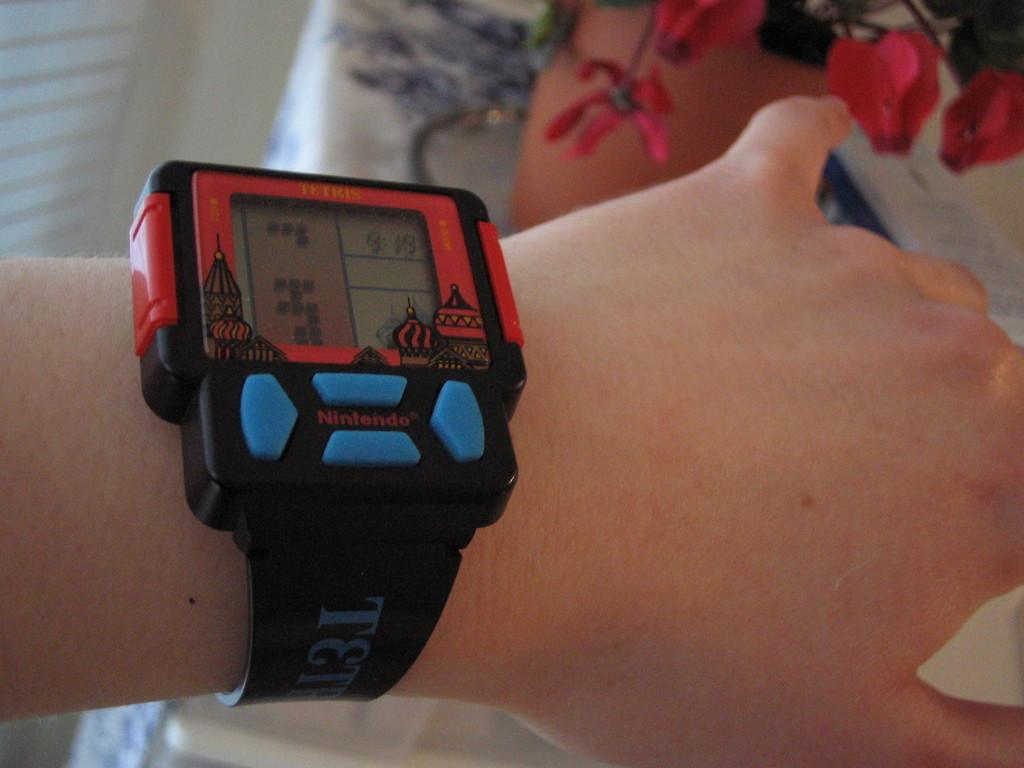<image>
Describe the image concisely. A wearable Tetris game device on a person's wrist. 